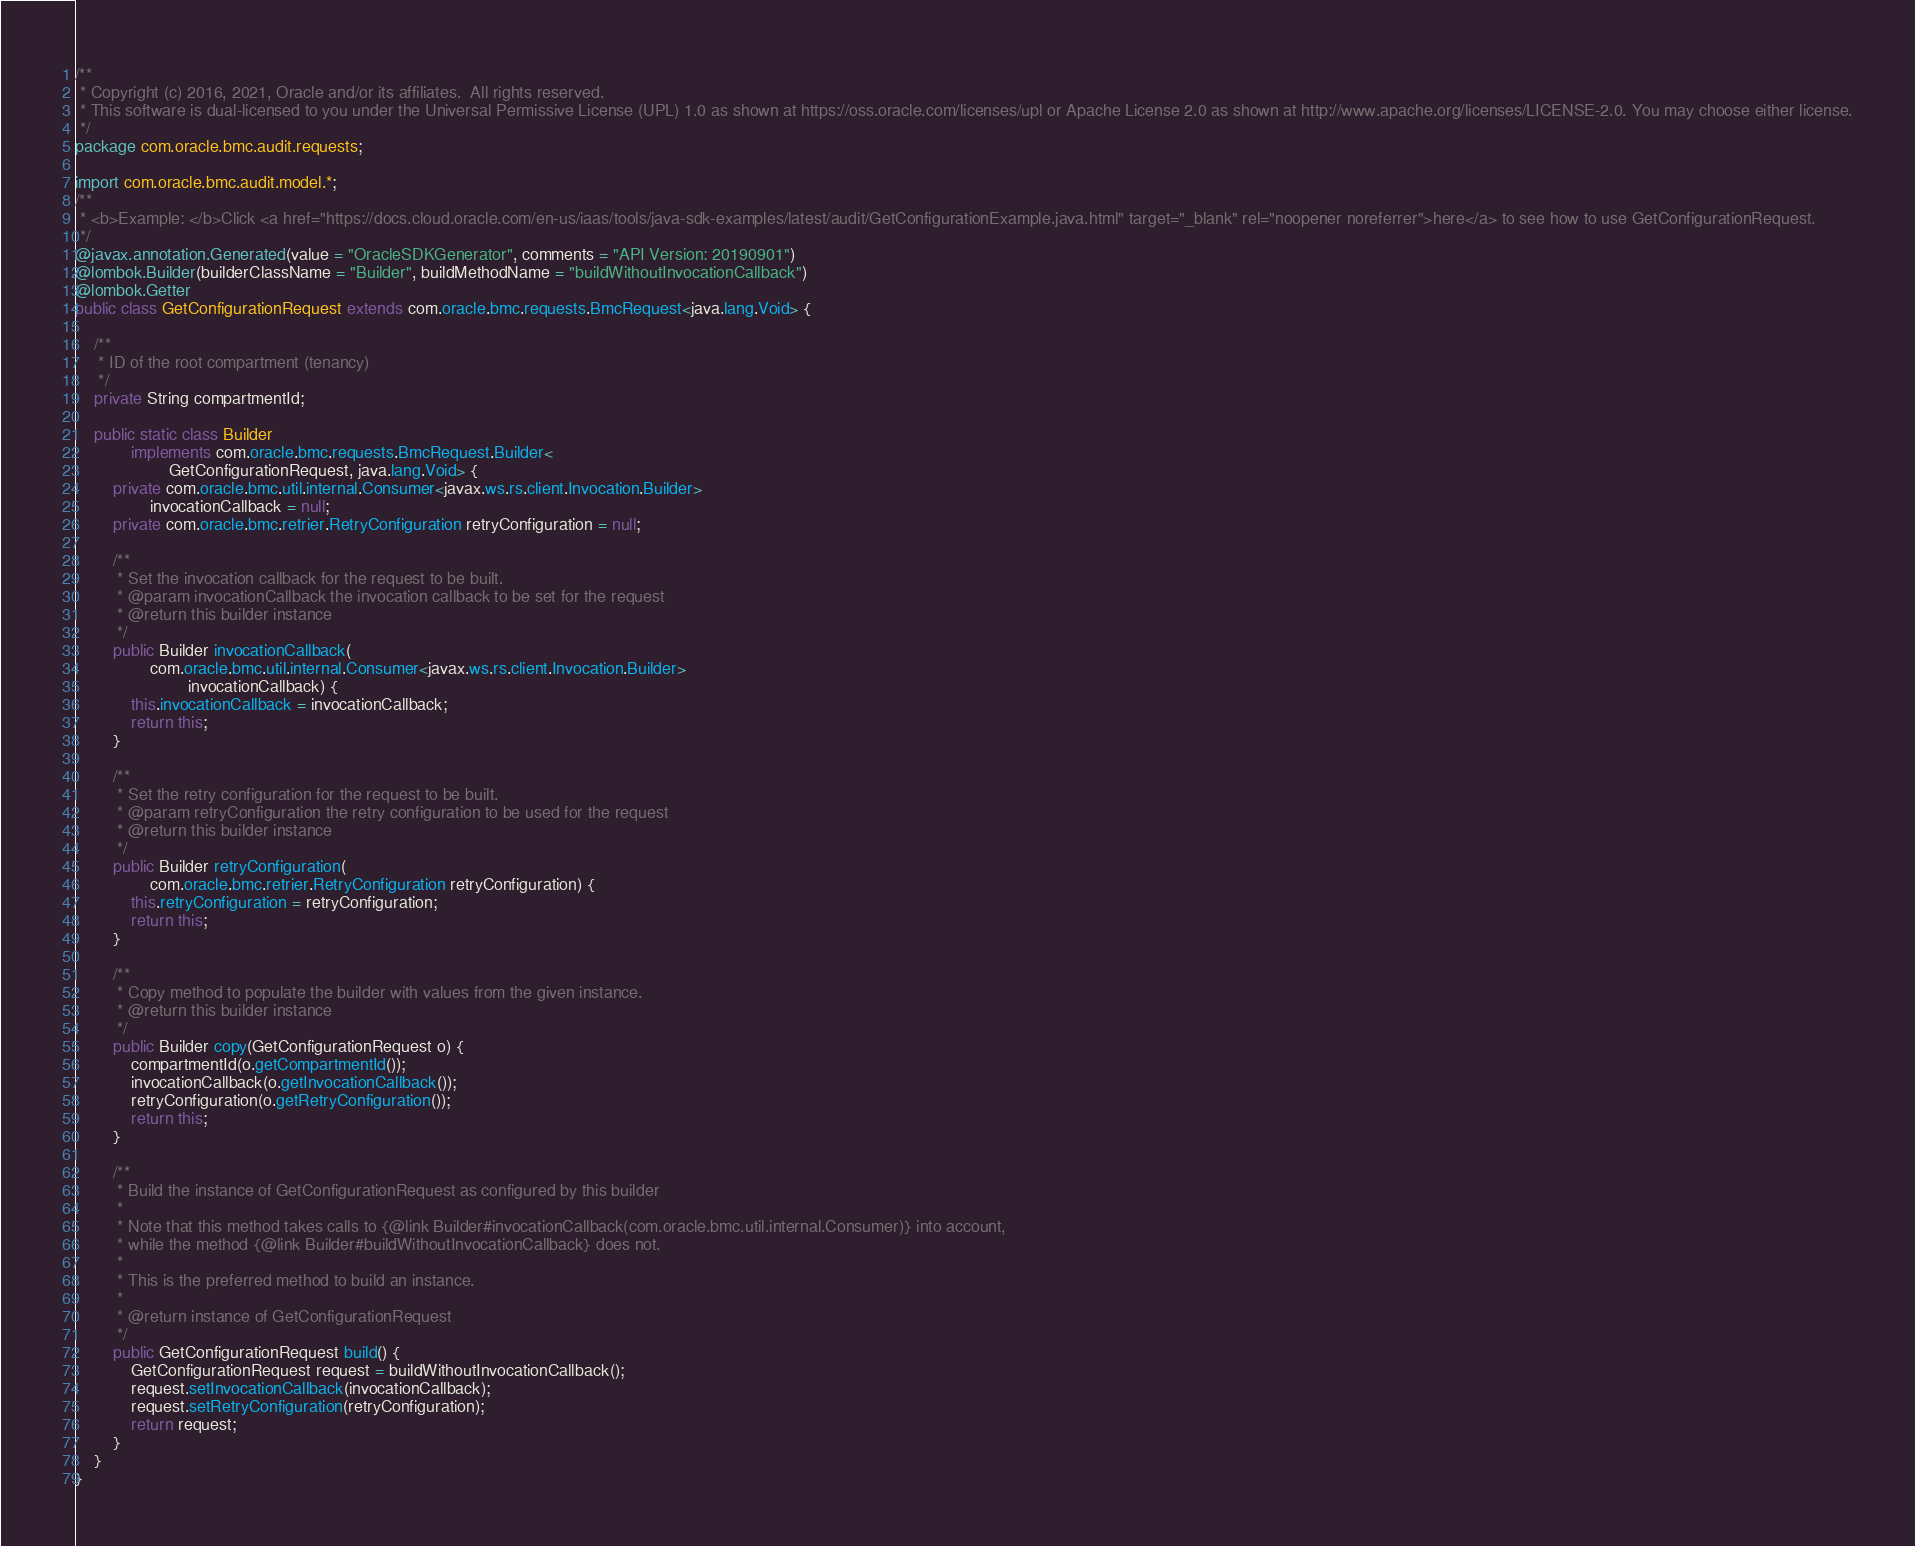<code> <loc_0><loc_0><loc_500><loc_500><_Java_>/**
 * Copyright (c) 2016, 2021, Oracle and/or its affiliates.  All rights reserved.
 * This software is dual-licensed to you under the Universal Permissive License (UPL) 1.0 as shown at https://oss.oracle.com/licenses/upl or Apache License 2.0 as shown at http://www.apache.org/licenses/LICENSE-2.0. You may choose either license.
 */
package com.oracle.bmc.audit.requests;

import com.oracle.bmc.audit.model.*;
/**
 * <b>Example: </b>Click <a href="https://docs.cloud.oracle.com/en-us/iaas/tools/java-sdk-examples/latest/audit/GetConfigurationExample.java.html" target="_blank" rel="noopener noreferrer">here</a> to see how to use GetConfigurationRequest.
 */
@javax.annotation.Generated(value = "OracleSDKGenerator", comments = "API Version: 20190901")
@lombok.Builder(builderClassName = "Builder", buildMethodName = "buildWithoutInvocationCallback")
@lombok.Getter
public class GetConfigurationRequest extends com.oracle.bmc.requests.BmcRequest<java.lang.Void> {

    /**
     * ID of the root compartment (tenancy)
     */
    private String compartmentId;

    public static class Builder
            implements com.oracle.bmc.requests.BmcRequest.Builder<
                    GetConfigurationRequest, java.lang.Void> {
        private com.oracle.bmc.util.internal.Consumer<javax.ws.rs.client.Invocation.Builder>
                invocationCallback = null;
        private com.oracle.bmc.retrier.RetryConfiguration retryConfiguration = null;

        /**
         * Set the invocation callback for the request to be built.
         * @param invocationCallback the invocation callback to be set for the request
         * @return this builder instance
         */
        public Builder invocationCallback(
                com.oracle.bmc.util.internal.Consumer<javax.ws.rs.client.Invocation.Builder>
                        invocationCallback) {
            this.invocationCallback = invocationCallback;
            return this;
        }

        /**
         * Set the retry configuration for the request to be built.
         * @param retryConfiguration the retry configuration to be used for the request
         * @return this builder instance
         */
        public Builder retryConfiguration(
                com.oracle.bmc.retrier.RetryConfiguration retryConfiguration) {
            this.retryConfiguration = retryConfiguration;
            return this;
        }

        /**
         * Copy method to populate the builder with values from the given instance.
         * @return this builder instance
         */
        public Builder copy(GetConfigurationRequest o) {
            compartmentId(o.getCompartmentId());
            invocationCallback(o.getInvocationCallback());
            retryConfiguration(o.getRetryConfiguration());
            return this;
        }

        /**
         * Build the instance of GetConfigurationRequest as configured by this builder
         *
         * Note that this method takes calls to {@link Builder#invocationCallback(com.oracle.bmc.util.internal.Consumer)} into account,
         * while the method {@link Builder#buildWithoutInvocationCallback} does not.
         *
         * This is the preferred method to build an instance.
         *
         * @return instance of GetConfigurationRequest
         */
        public GetConfigurationRequest build() {
            GetConfigurationRequest request = buildWithoutInvocationCallback();
            request.setInvocationCallback(invocationCallback);
            request.setRetryConfiguration(retryConfiguration);
            return request;
        }
    }
}
</code> 